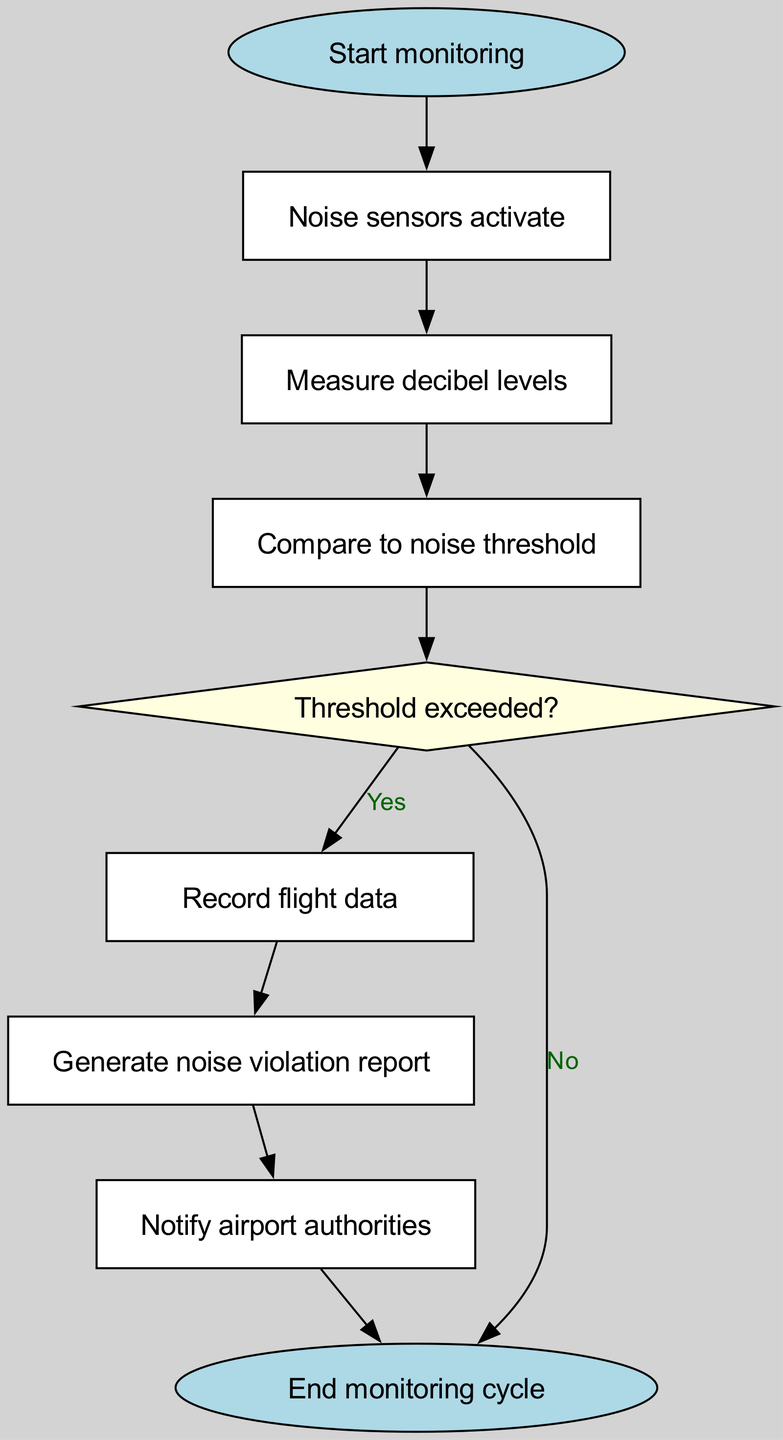What is the starting point of the workflow? The starting point is the node labeled "Start monitoring," which initiates the flow of the process.
Answer: Start monitoring How many edges are in the diagram? There are nine edges connecting the nodes in the flowchart, representing the flow of actions and decisions.
Answer: 9 What happens if the noise threshold is exceeded? If the noise threshold is exceeded, the flow moves to the "Record flight data" node, indicating that further actions will be taken to document the event.
Answer: Record flight data What is the shape of the node that compares noise levels to the threshold? The node that compares noise levels to the threshold has a rectangular shape, which indicates a standard process in the workflow.
Answer: Rectangle What is generated after recording flight data? After recording flight data, the next step in the flowchart is to "Generate noise violation report," which indicates the documentation of the violation is created.
Answer: Generate noise violation report What action is taken if the threshold is not exceeded? If the threshold is not exceeded, the flow directly proceeds to the "End monitoring cycle" node, indicating that no further action is necessary.
Answer: End monitoring cycle Which node is responsible for notifying airport authorities? The node tasked with notifying airport authorities is labeled "Notify airport authorities," linking the report generation to the relevant authorities.
Answer: Notify airport authorities What type of node indicates a decision point in the workflow? The diamond-shaped node indicates a decision point in the workflow; it represents a conditional question that directs the flow based on the outcome.
Answer: Diamond What fills the node representing noise sensors activation? The node for "Noise sensors activate" is filled with white color, distinguishing it from decision points and start/end nodes visually.
Answer: White 